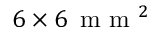<formula> <loc_0><loc_0><loc_500><loc_500>6 \times 6 \, m m ^ { 2 }</formula> 